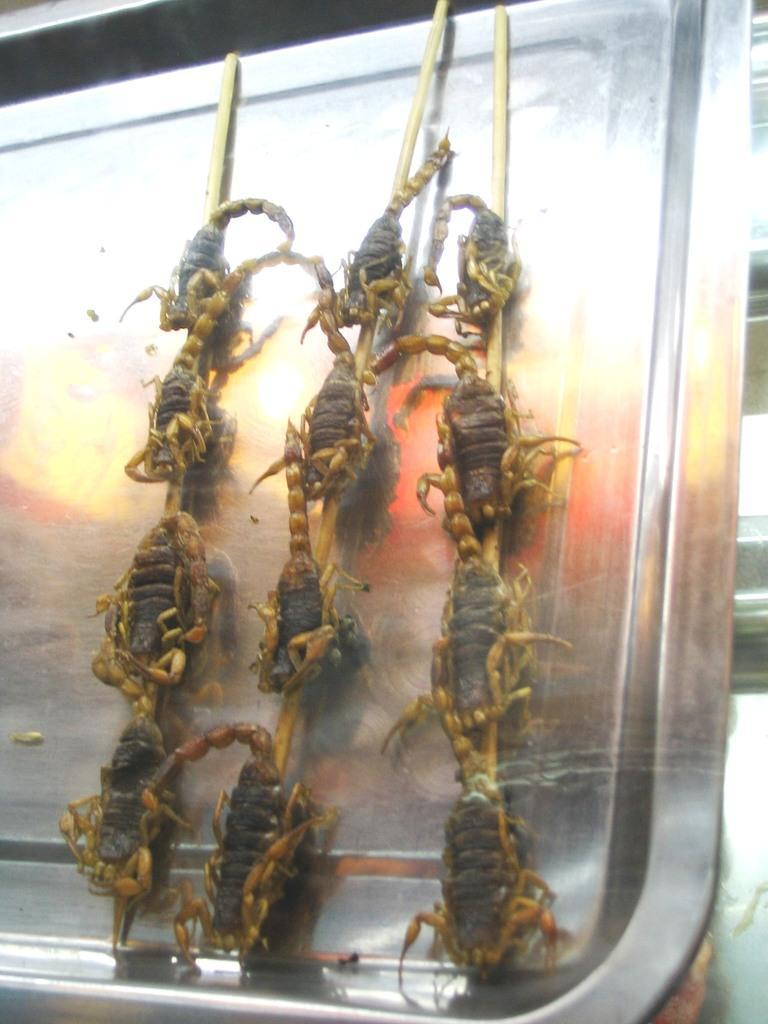In one or two sentences, can you explain what this image depicts? In this picture we can see sticks, animals are on a metal object and in the background we can see some objects. 